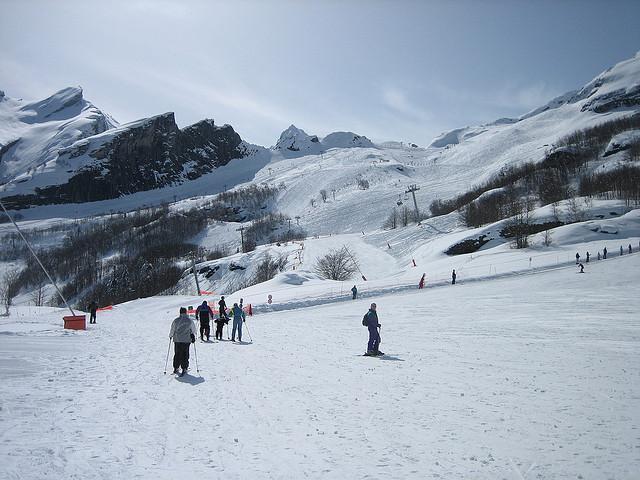What is the elevated metal railway called?
From the following four choices, select the correct answer to address the question.
Options: Zip line, sky taxi, sky elevation, ski lift. Ski lift. 